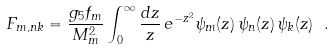<formula> <loc_0><loc_0><loc_500><loc_500>F _ { m , n k } = \frac { g _ { 5 } f _ { m } } { M _ { m } ^ { 2 } } \int ^ { \infty } _ { 0 } \frac { d z } { z } \, e ^ { - z ^ { 2 } } \psi _ { m } ( z ) \, \psi _ { n } ( z ) \, \psi _ { k } ( z ) \ .</formula> 